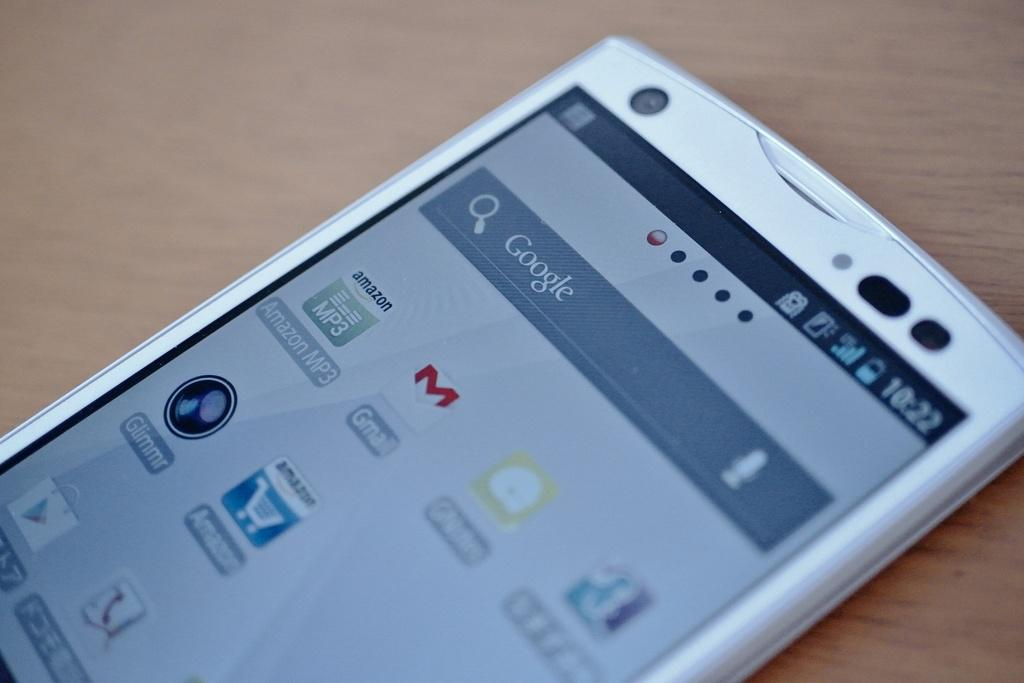What electronic device is visible in the image? There is a mobile phone in the image. Where is the mobile phone located? The mobile phone is on a table. What type of street scene can be seen in the image? There is no street scene present in the image; it only features a mobile phone on a table. 